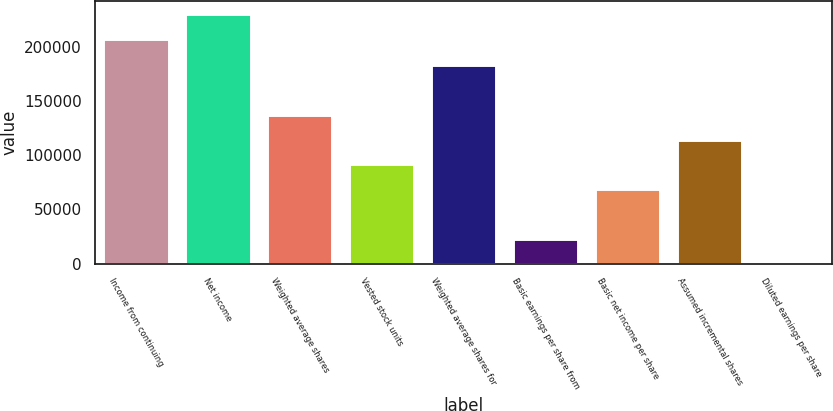<chart> <loc_0><loc_0><loc_500><loc_500><bar_chart><fcel>Income from continuing<fcel>Net income<fcel>Weighted average shares<fcel>Vested stock units<fcel>Weighted average shares for<fcel>Basic earnings per share from<fcel>Basic net income per share<fcel>Assumed incremental shares<fcel>Diluted earnings per share<nl><fcel>207422<fcel>230286<fcel>137187<fcel>91458.4<fcel>182915<fcel>22866.1<fcel>68594.3<fcel>114322<fcel>1.99<nl></chart> 